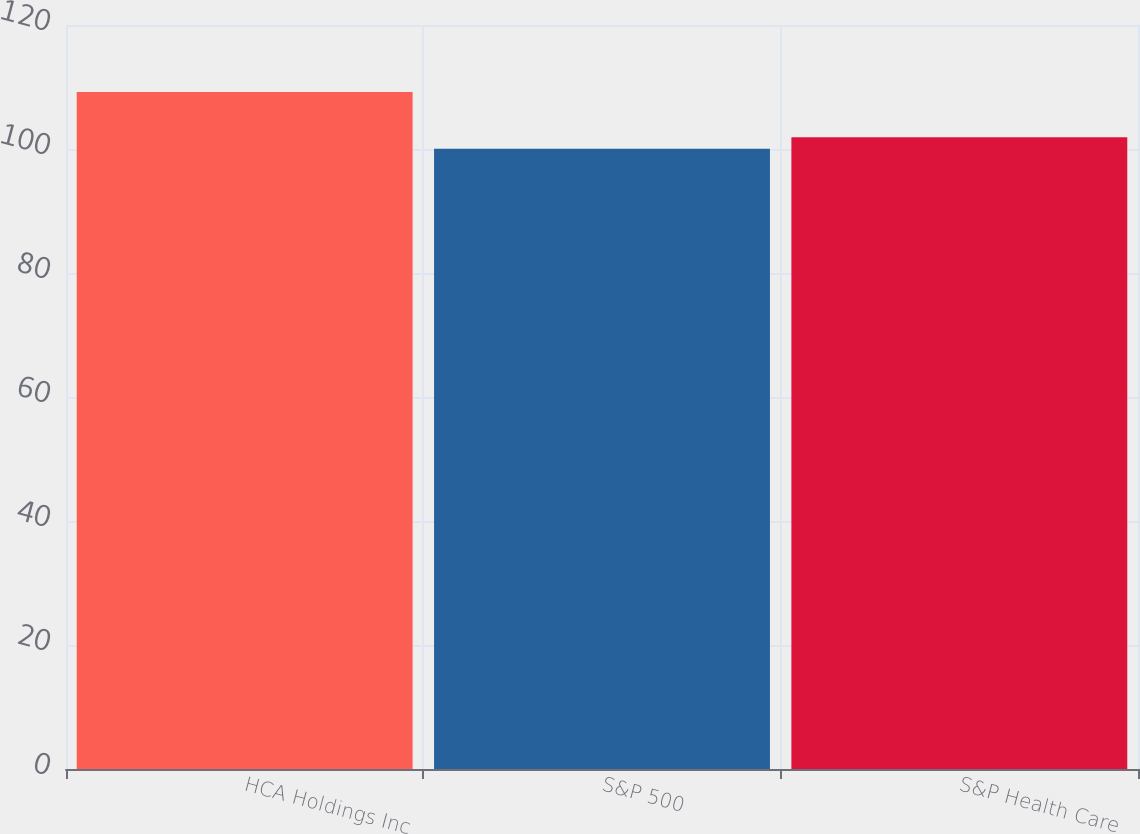<chart> <loc_0><loc_0><loc_500><loc_500><bar_chart><fcel>HCA Holdings Inc<fcel>S&P 500<fcel>S&P Health Care<nl><fcel>109.19<fcel>100.04<fcel>101.9<nl></chart> 